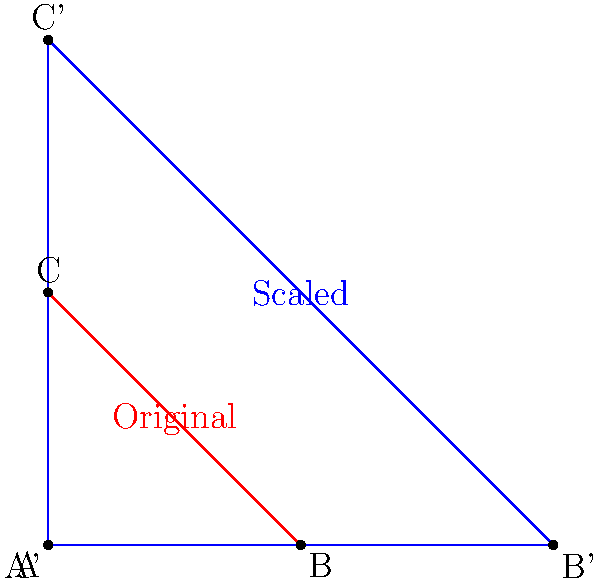A heart-shaped figure is represented by a triangle ABC. To symbolize growing love and support, the figure is scaled by a factor of 2. If the area of the original heart-shaped figure is 24 square units, what is the area of the scaled figure? Let's approach this step-by-step:

1) The original heart-shaped figure is represented by triangle ABC with an area of 24 square units.

2) The scaling factor is 2, which means all dimensions of the figure are doubled.

3) In transformational geometry, when a figure is scaled by a factor of k, its area is multiplied by $k^2$.

4) In this case, $k = 2$, so the area will be multiplied by $2^2 = 4$.

5) Therefore, the new area will be:
   $\text{New Area} = \text{Original Area} \times 4$
   $\text{New Area} = 24 \times 4 = 96$ square units

This scaling represents the growth of love and support, as the heart-shaped figure has become four times larger in area.
Answer: 96 square units 